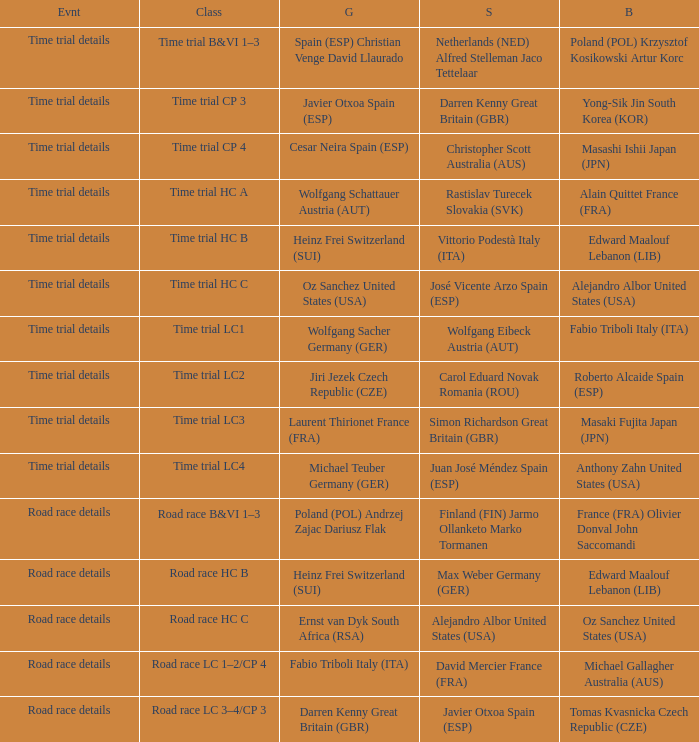Who received gold when the event is time trial details and silver is simon richardson great britain (gbr)? Laurent Thirionet France (FRA). 